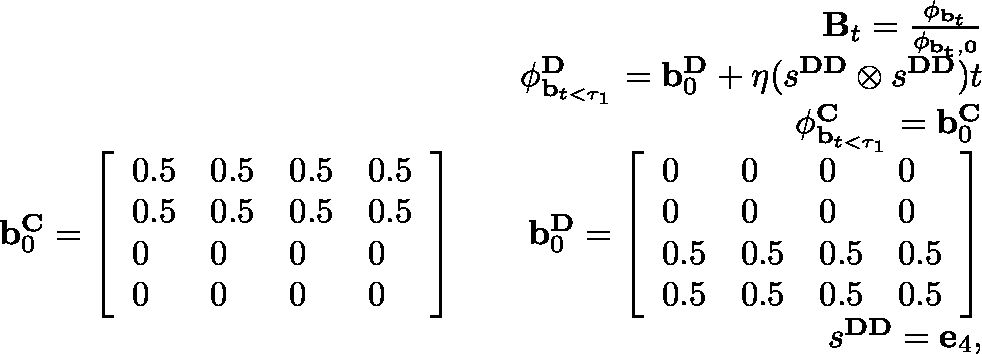Convert formula to latex. <formula><loc_0><loc_0><loc_500><loc_500>\begin{array} { r } { B _ { t } = \frac { \phi _ { b _ { t } } } { \phi _ { { b } _ { t } , 0 } } } \\ { \phi _ { b _ { t < \tau _ { 1 } } } ^ { D } = b _ { 0 } ^ { D } + \eta ( s ^ { D D } \otimes s ^ { D D } ) t } \\ { \phi _ { b _ { t < \tau _ { 1 } } } ^ { C } = b _ { 0 } ^ { C } } \\ { b _ { 0 } ^ { C } = \left [ \begin{array} { l l l l } { 0 . 5 } & { 0 . 5 } & { 0 . 5 } & { 0 . 5 } \\ { 0 . 5 } & { 0 . 5 } & { 0 . 5 } & { 0 . 5 } \\ { 0 } & { 0 } & { 0 } & { 0 } \\ { 0 } & { 0 } & { 0 } & { 0 } \end{array} \right ] \quad b _ { 0 } ^ { D } = \left [ \begin{array} { l l l l } { 0 } & { 0 } & { 0 } & { 0 } \\ { 0 } & { 0 } & { 0 } & { 0 } \\ { 0 . 5 } & { 0 . 5 } & { 0 . 5 } & { 0 . 5 } \\ { 0 . 5 } & { 0 . 5 } & { 0 . 5 } & { 0 . 5 } \end{array} \right ] } \\ { s ^ { D D } = e _ { 4 } , } \end{array}</formula> 